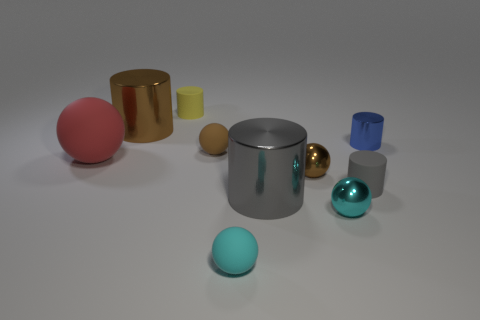Subtract all blue metal cylinders. How many cylinders are left? 4 Subtract all yellow cylinders. How many cylinders are left? 4 Subtract 0 cyan cylinders. How many objects are left? 10 Subtract 2 cylinders. How many cylinders are left? 3 Subtract all purple spheres. Subtract all yellow blocks. How many spheres are left? 5 Subtract all brown cylinders. How many cyan balls are left? 2 Subtract all big red blocks. Subtract all big red matte balls. How many objects are left? 9 Add 1 small cyan rubber objects. How many small cyan rubber objects are left? 2 Add 3 large gray cylinders. How many large gray cylinders exist? 4 